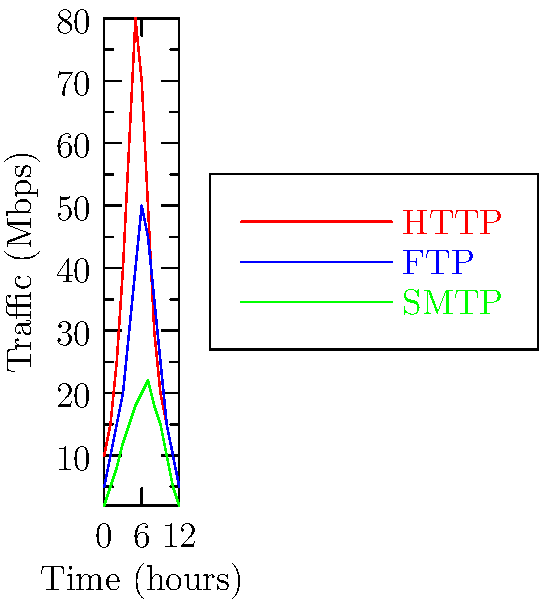Analyze the network traffic patterns represented in the line graph. At what time does the combined traffic from all three protocols (HTTP, FTP, and SMTP) reach its peak? Express your answer in hours. To find the peak of combined traffic, we need to follow these steps:

1. For each time point, sum the traffic values for all three protocols (HTTP, FTP, and SMTP).
2. Identify the highest sum, which represents the peak of combined traffic.
3. Note the corresponding time for this peak.

Let's calculate the sums for each hour:

Hour 0: $10 + 5 + 2 = 17$ Mbps
Hour 1: $15 + 10 + 5 = 30$ Mbps
Hour 2: $25 + 15 + 8 = 48$ Mbps
Hour 3: $40 + 20 + 12 = 72$ Mbps
Hour 4: $60 + 30 + 15 = 105$ Mbps
Hour 5: $80 + 40 + 18 = 138$ Mbps
Hour 6: $70 + 50 + 20 = 140$ Mbps
Hour 7: $50 + 45 + 22 = 117$ Mbps
Hour 8: $30 + 35 + 18 = 83$ Mbps
Hour 9: $20 + 25 + 15 = 60$ Mbps
Hour 10: $15 + 15 + 10 = 40$ Mbps
Hour 11: $10 + 10 + 5 = 25$ Mbps
Hour 12: $5 + 5 + 2 = 12$ Mbps

The highest combined traffic is 140 Mbps, occurring at hour 6.
Answer: 6 